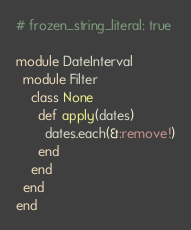Convert code to text. <code><loc_0><loc_0><loc_500><loc_500><_Ruby_># frozen_string_literal: true

module DateInterval
  module Filter
    class None
      def apply(dates)
        dates.each(&:remove!)
      end
    end
  end
end
</code> 